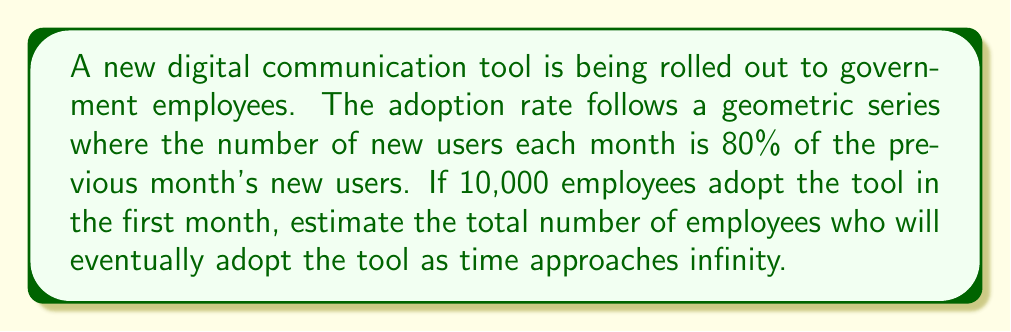Can you solve this math problem? Let's approach this step-by-step:

1) The geometric series representing the adoption rate can be written as:

   $$S_{\infty} = a + ar + ar^2 + ar^3 + ...$$

   where $a$ is the initial number of adopters and $r$ is the common ratio.

2) In this case:
   $a = 10,000$ (initial adopters)
   $r = 0.8$ (80% of previous month's new users)

3) For an infinite geometric series to converge, we need $|r| < 1$. Here, $r = 0.8$, so the series converges.

4) The sum of an infinite converging geometric series is given by the formula:

   $$S_{\infty} = \frac{a}{1-r}$$

5) Substituting our values:

   $$S_{\infty} = \frac{10,000}{1-0.8}$$

6) Simplifying:

   $$S_{\infty} = \frac{10,000}{0.2} = 50,000$$

Therefore, as time approaches infinity, approximately 50,000 employees will adopt the new digital communication tool.
Answer: 50,000 employees 